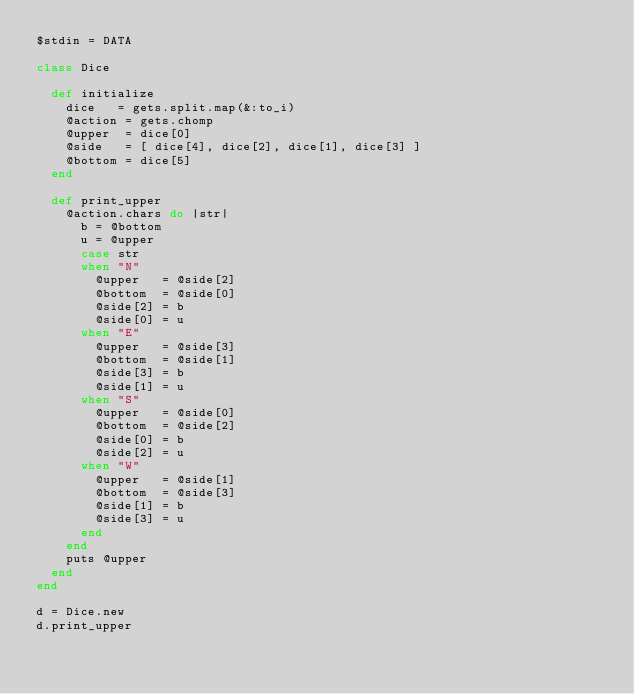Convert code to text. <code><loc_0><loc_0><loc_500><loc_500><_Ruby_>$stdin = DATA

class Dice

  def initialize
    dice   = gets.split.map(&:to_i)
    @action = gets.chomp
    @upper  = dice[0]
    @side   = [ dice[4], dice[2], dice[1], dice[3] ]
    @bottom = dice[5]
  end

  def print_upper
    @action.chars do |str|
      b = @bottom
      u = @upper
      case str
      when "N"
        @upper   = @side[2]
        @bottom  = @side[0]
        @side[2] = b
        @side[0] = u
      when "E"
        @upper   = @side[3]
        @bottom  = @side[1]
        @side[3] = b
        @side[1] = u
      when "S"
        @upper   = @side[0]
        @bottom  = @side[2]
        @side[0] = b
        @side[2] = u
      when "W"
        @upper   = @side[1]
        @bottom  = @side[3]
        @side[1] = b
        @side[3] = u
      end
    end
    puts @upper
  end
end

d = Dice.new
d.print_upper</code> 